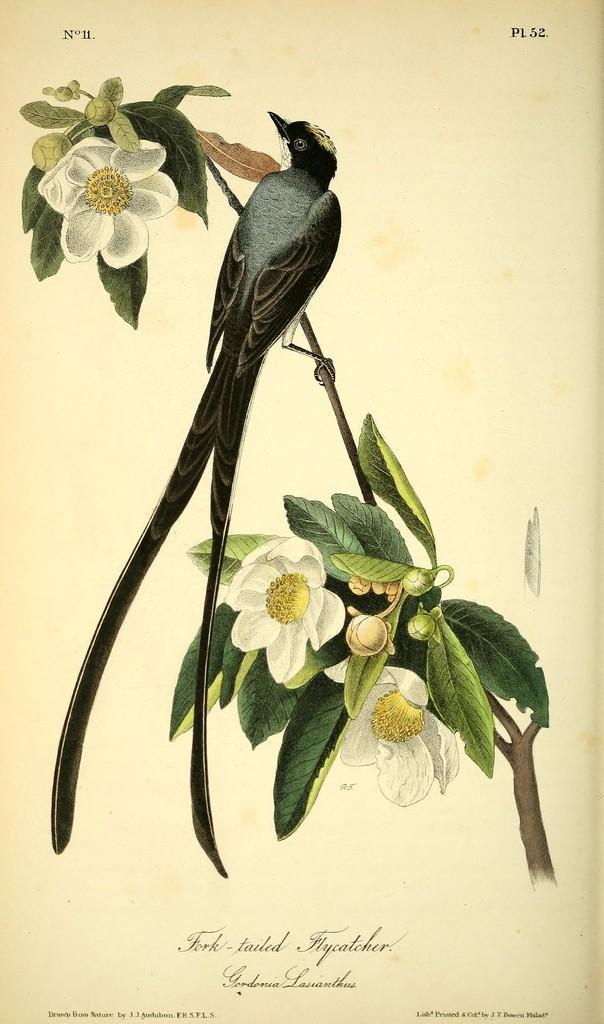In one or two sentences, can you explain what this image depicts? The picture consists of a painting, in the painting there are leaves, flowers, buds and stem. In the center there is a bird sitting on the stem. At the bottom there is text. 